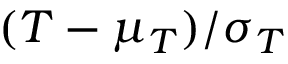Convert formula to latex. <formula><loc_0><loc_0><loc_500><loc_500>( T - \mu _ { T } ) / \sigma _ { T }</formula> 